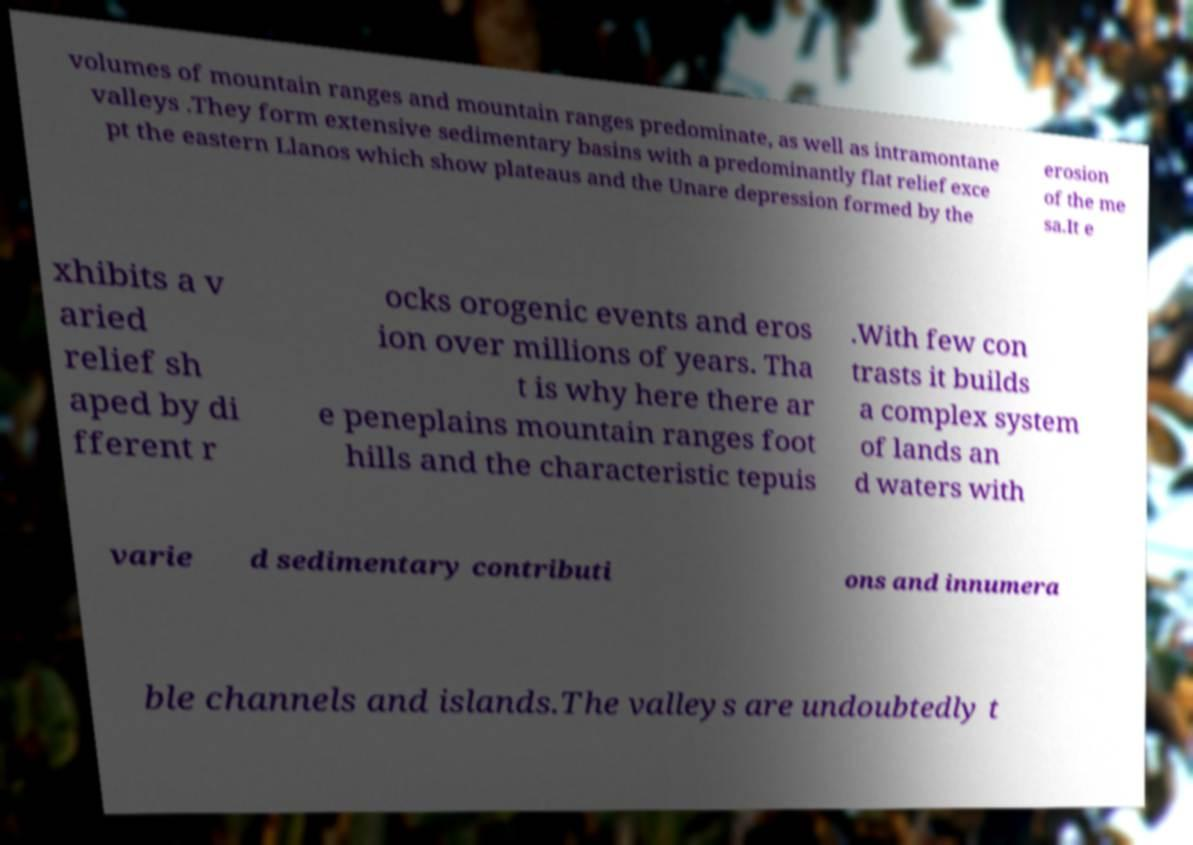There's text embedded in this image that I need extracted. Can you transcribe it verbatim? volumes of mountain ranges and mountain ranges predominate, as well as intramontane valleys .They form extensive sedimentary basins with a predominantly flat relief exce pt the eastern Llanos which show plateaus and the Unare depression formed by the erosion of the me sa.It e xhibits a v aried relief sh aped by di fferent r ocks orogenic events and eros ion over millions of years. Tha t is why here there ar e peneplains mountain ranges foot hills and the characteristic tepuis .With few con trasts it builds a complex system of lands an d waters with varie d sedimentary contributi ons and innumera ble channels and islands.The valleys are undoubtedly t 